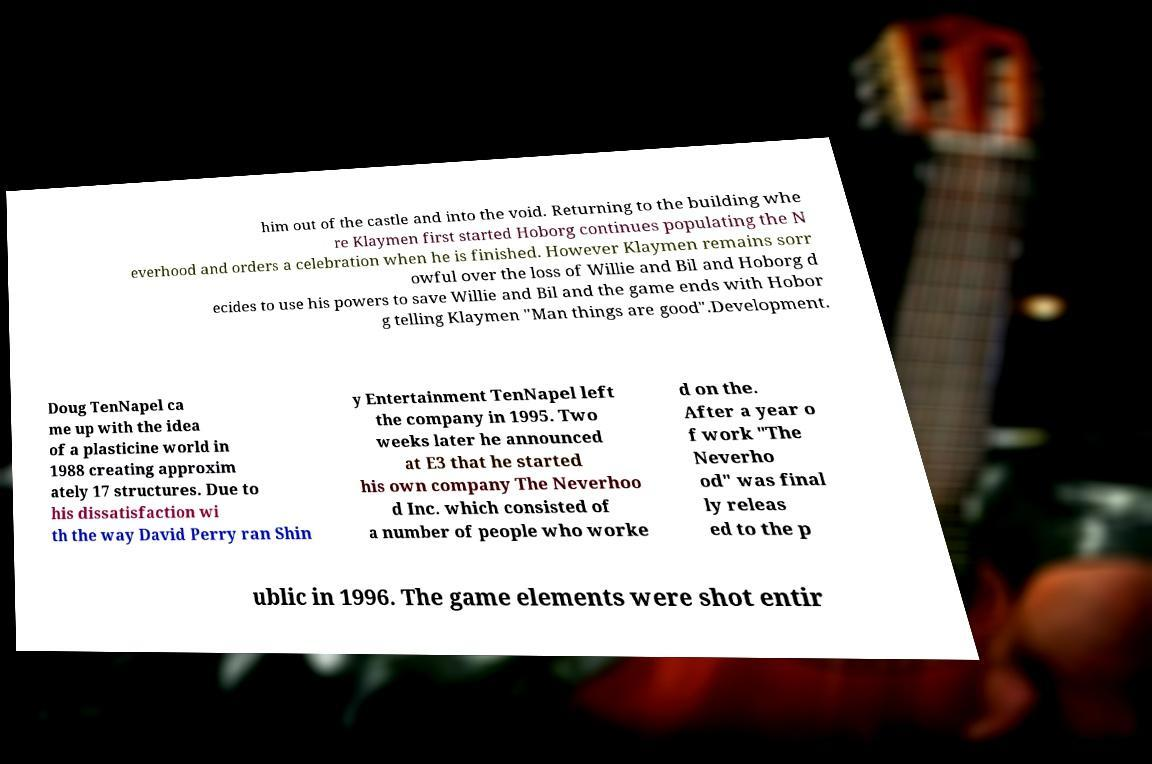Could you extract and type out the text from this image? him out of the castle and into the void. Returning to the building whe re Klaymen first started Hoborg continues populating the N everhood and orders a celebration when he is finished. However Klaymen remains sorr owful over the loss of Willie and Bil and Hoborg d ecides to use his powers to save Willie and Bil and the game ends with Hobor g telling Klaymen "Man things are good".Development. Doug TenNapel ca me up with the idea of a plasticine world in 1988 creating approxim ately 17 structures. Due to his dissatisfaction wi th the way David Perry ran Shin y Entertainment TenNapel left the company in 1995. Two weeks later he announced at E3 that he started his own company The Neverhoo d Inc. which consisted of a number of people who worke d on the. After a year o f work "The Neverho od" was final ly releas ed to the p ublic in 1996. The game elements were shot entir 